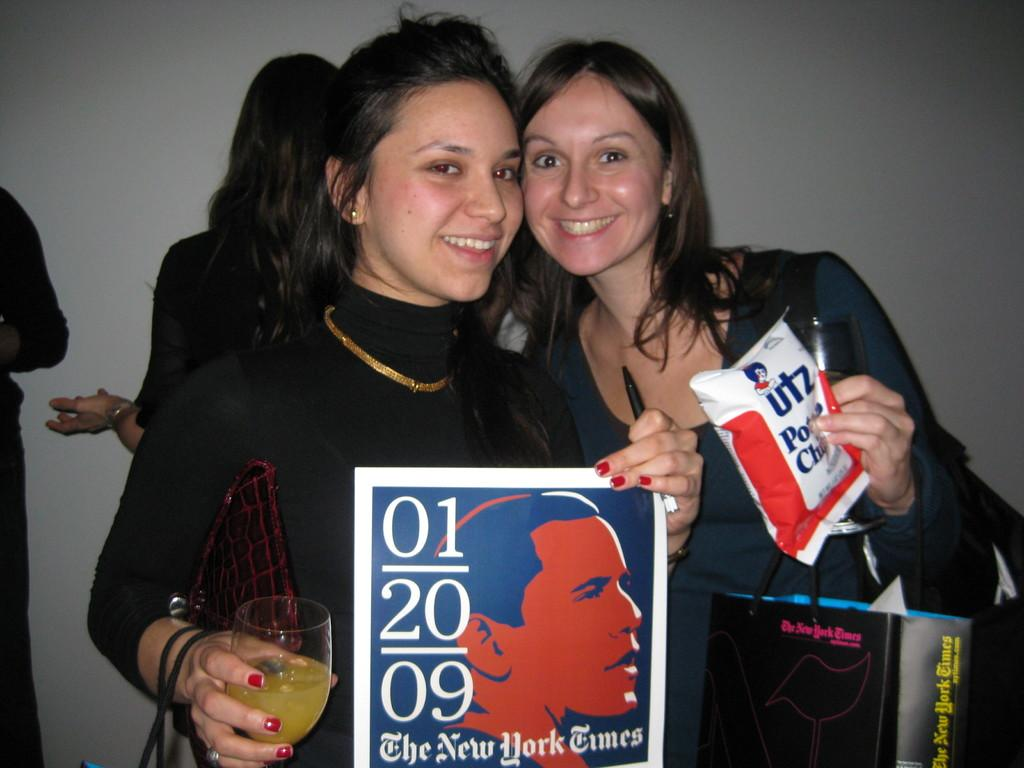What is the main subject of the image? The main subject of the image is a group of people. Can you describe the actions of the two women in the group? The two women are holding a packet and a glass in their hands. What is the emotional expression of the women in the image? The women are smiling. What type of authority do the women in the image hold? There is no indication of any authority held by the women in the image. What books are the women reading in the image? There are no books present in the image. 